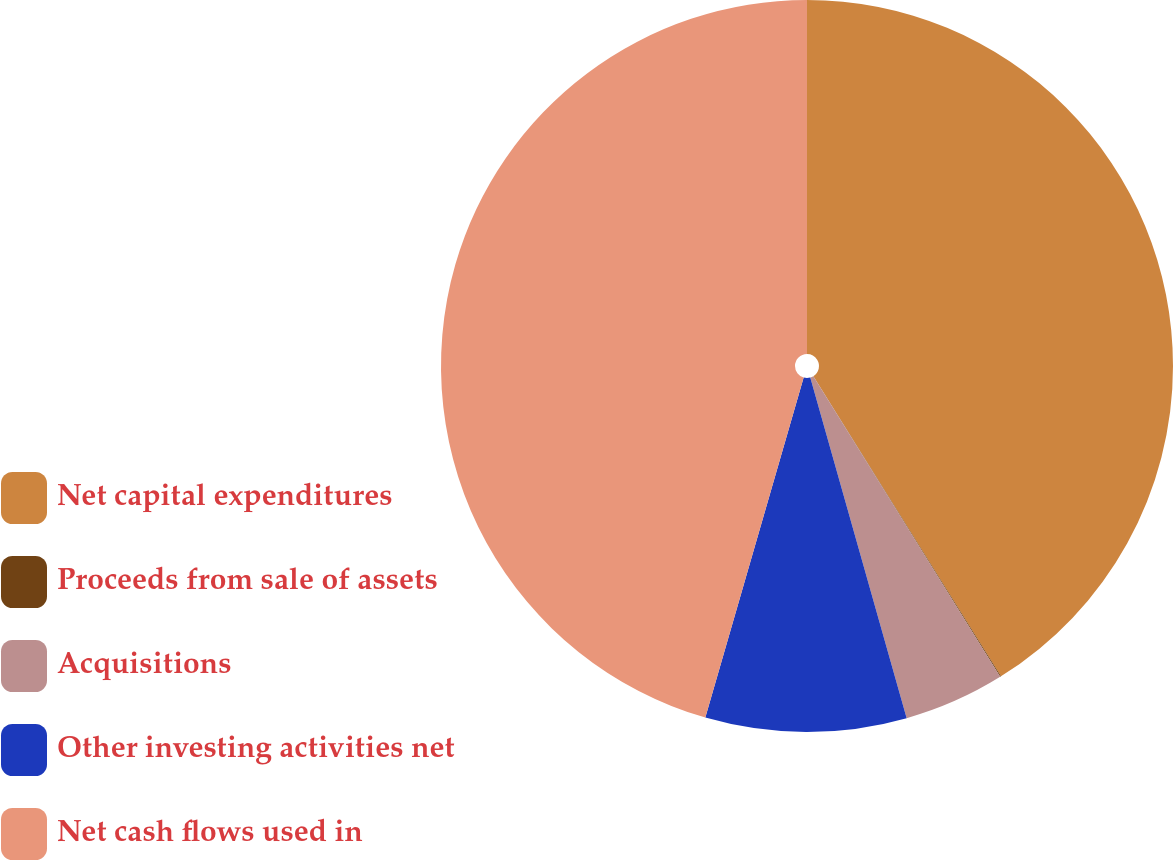<chart> <loc_0><loc_0><loc_500><loc_500><pie_chart><fcel>Net capital expenditures<fcel>Proceeds from sale of assets<fcel>Acquisitions<fcel>Other investing activities net<fcel>Net cash flows used in<nl><fcel>41.11%<fcel>0.04%<fcel>4.46%<fcel>8.87%<fcel>45.52%<nl></chart> 